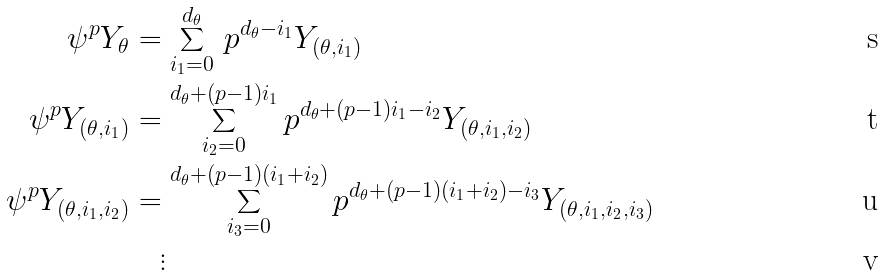Convert formula to latex. <formula><loc_0><loc_0><loc_500><loc_500>\psi ^ { p } Y _ { \theta } & = \sum _ { i _ { 1 } = 0 } ^ { d _ { \theta } } \, p ^ { d _ { \theta } - i _ { 1 } } Y _ { ( \theta , i _ { 1 } ) } \\ \psi ^ { p } Y _ { ( \theta , i _ { 1 } ) } & = \sum _ { i _ { 2 } = 0 } ^ { d _ { \theta } + ( p - 1 ) i _ { 1 } } p ^ { d _ { \theta } + ( p - 1 ) i _ { 1 } - i _ { 2 } } Y _ { ( \theta , i _ { 1 } , i _ { 2 } ) } \\ \psi ^ { p } Y _ { ( \theta , i _ { 1 } , i _ { 2 } ) } & = \sum _ { i _ { 3 } = 0 } ^ { d _ { \theta } + ( p - 1 ) ( i _ { 1 } + i _ { 2 } ) } p ^ { d _ { \theta } + ( p - 1 ) ( i _ { 1 } + i _ { 2 } ) - i _ { 3 } } Y _ { ( \theta , i _ { 1 } , i _ { 2 } , i _ { 3 } ) } \\ & \quad \vdots</formula> 